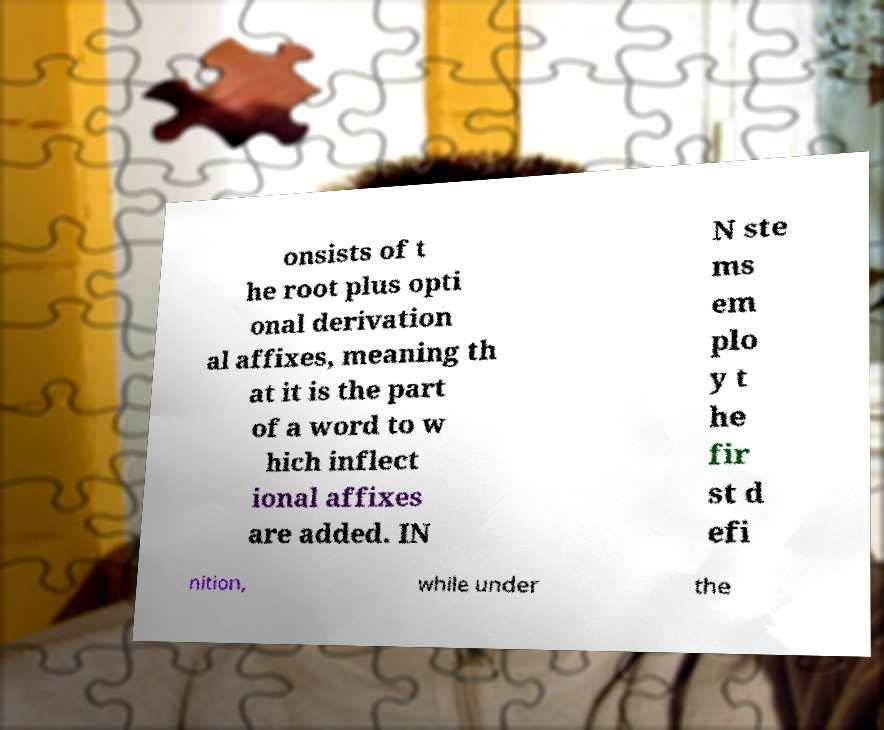Can you read and provide the text displayed in the image?This photo seems to have some interesting text. Can you extract and type it out for me? onsists of t he root plus opti onal derivation al affixes, meaning th at it is the part of a word to w hich inflect ional affixes are added. IN N ste ms em plo y t he fir st d efi nition, while under the 